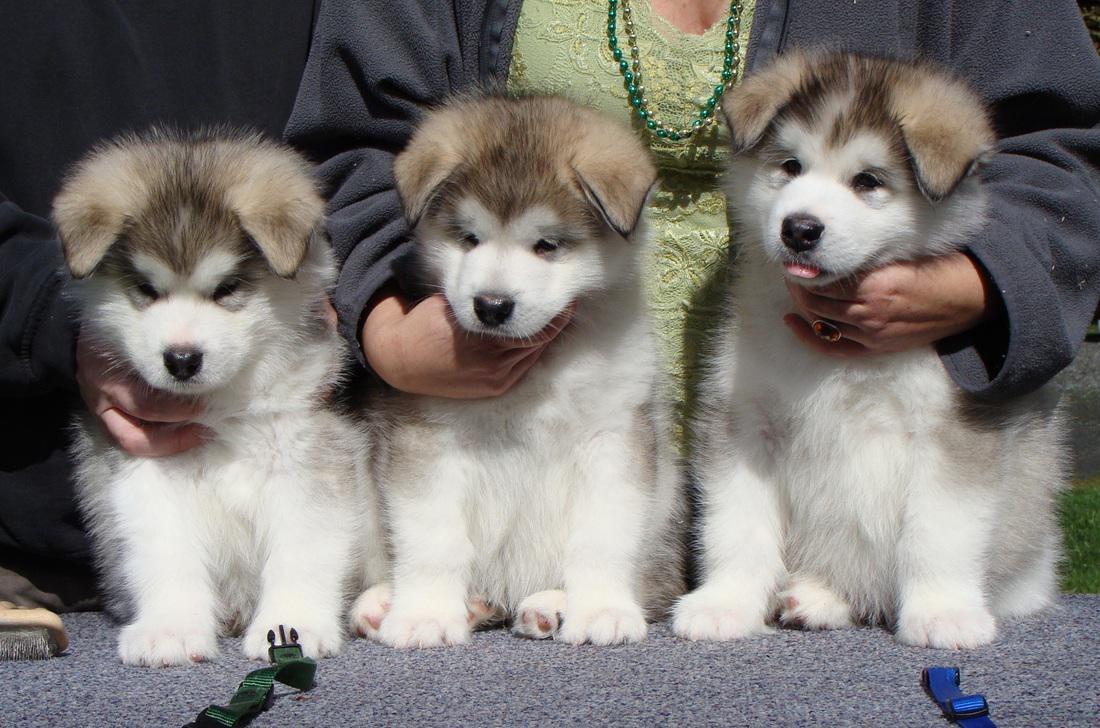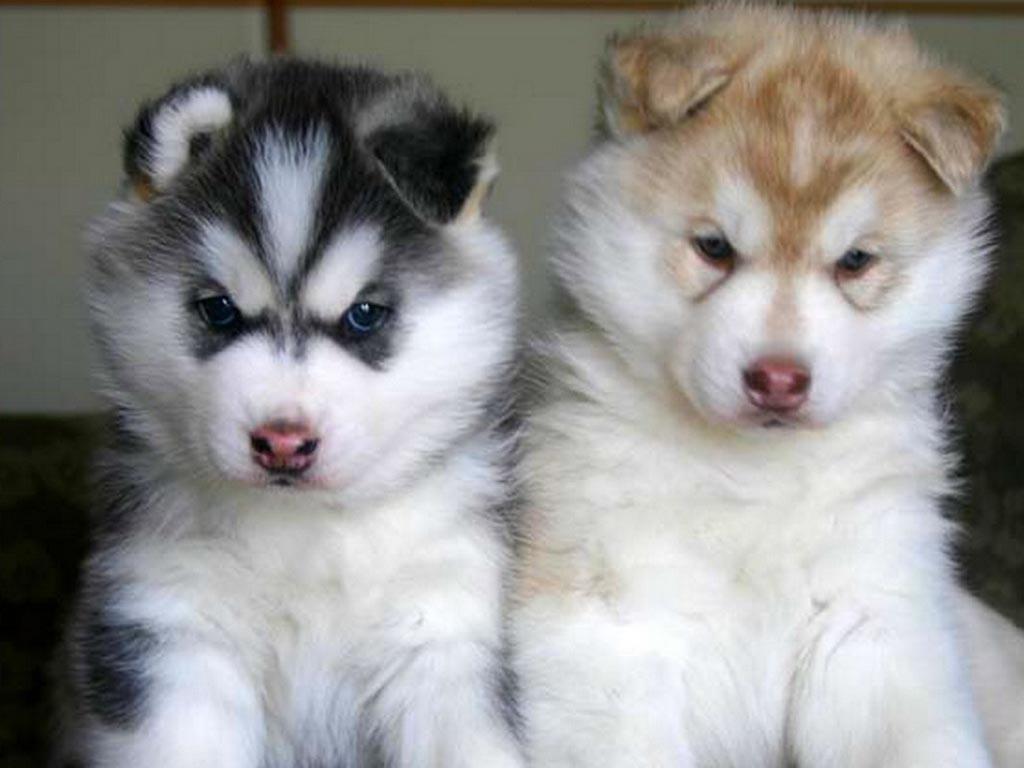The first image is the image on the left, the second image is the image on the right. Given the left and right images, does the statement "There is one puppy with black fur, and the other dogs have brown fur." hold true? Answer yes or no. Yes. The first image is the image on the left, the second image is the image on the right. Analyze the images presented: Is the assertion "The right image features two side-by-side forward-facing puppies with closed mouths." valid? Answer yes or no. Yes. 